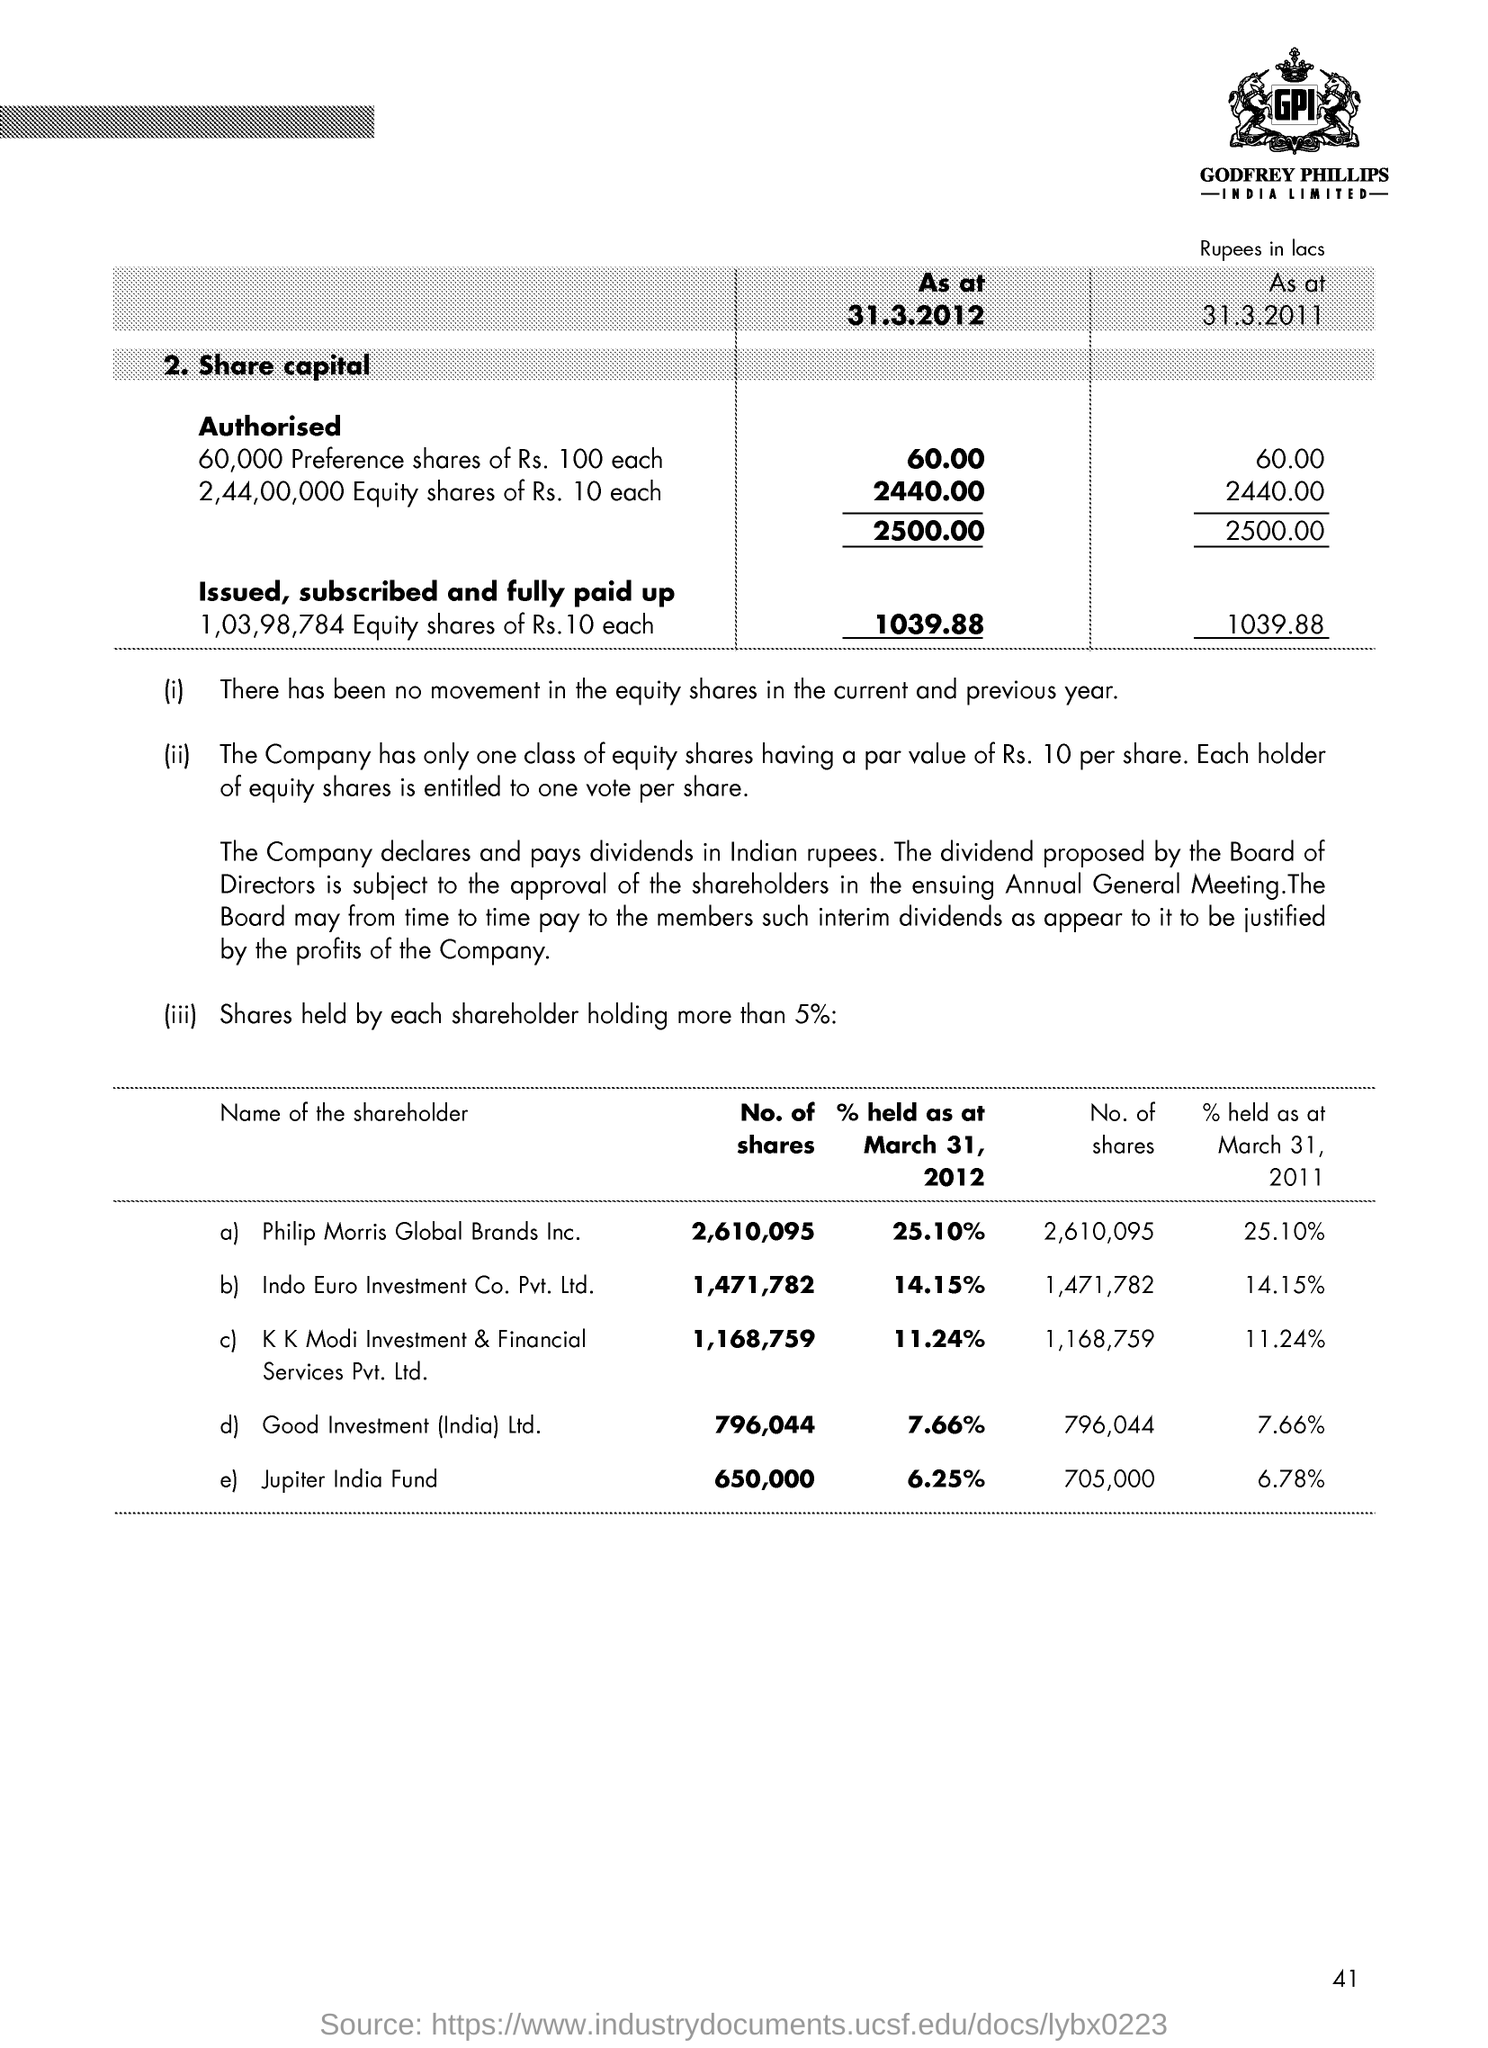List a handful of essential elements in this visual. The page number is 41. As of March 31, 2012, Philip Morris Global Brands Inc. held a total of 2,610,095 shares. As of March 31, 2011, Jupiter India Fund held approximately 6.78% of the shares outstanding. As of March 31, 2012, Philip Morris Global Brands Inc. held 25.10% of the outstanding shares of the company. Jupiter India Fund was the shareholder with the minimum number of shares as of March 31, 2012. 